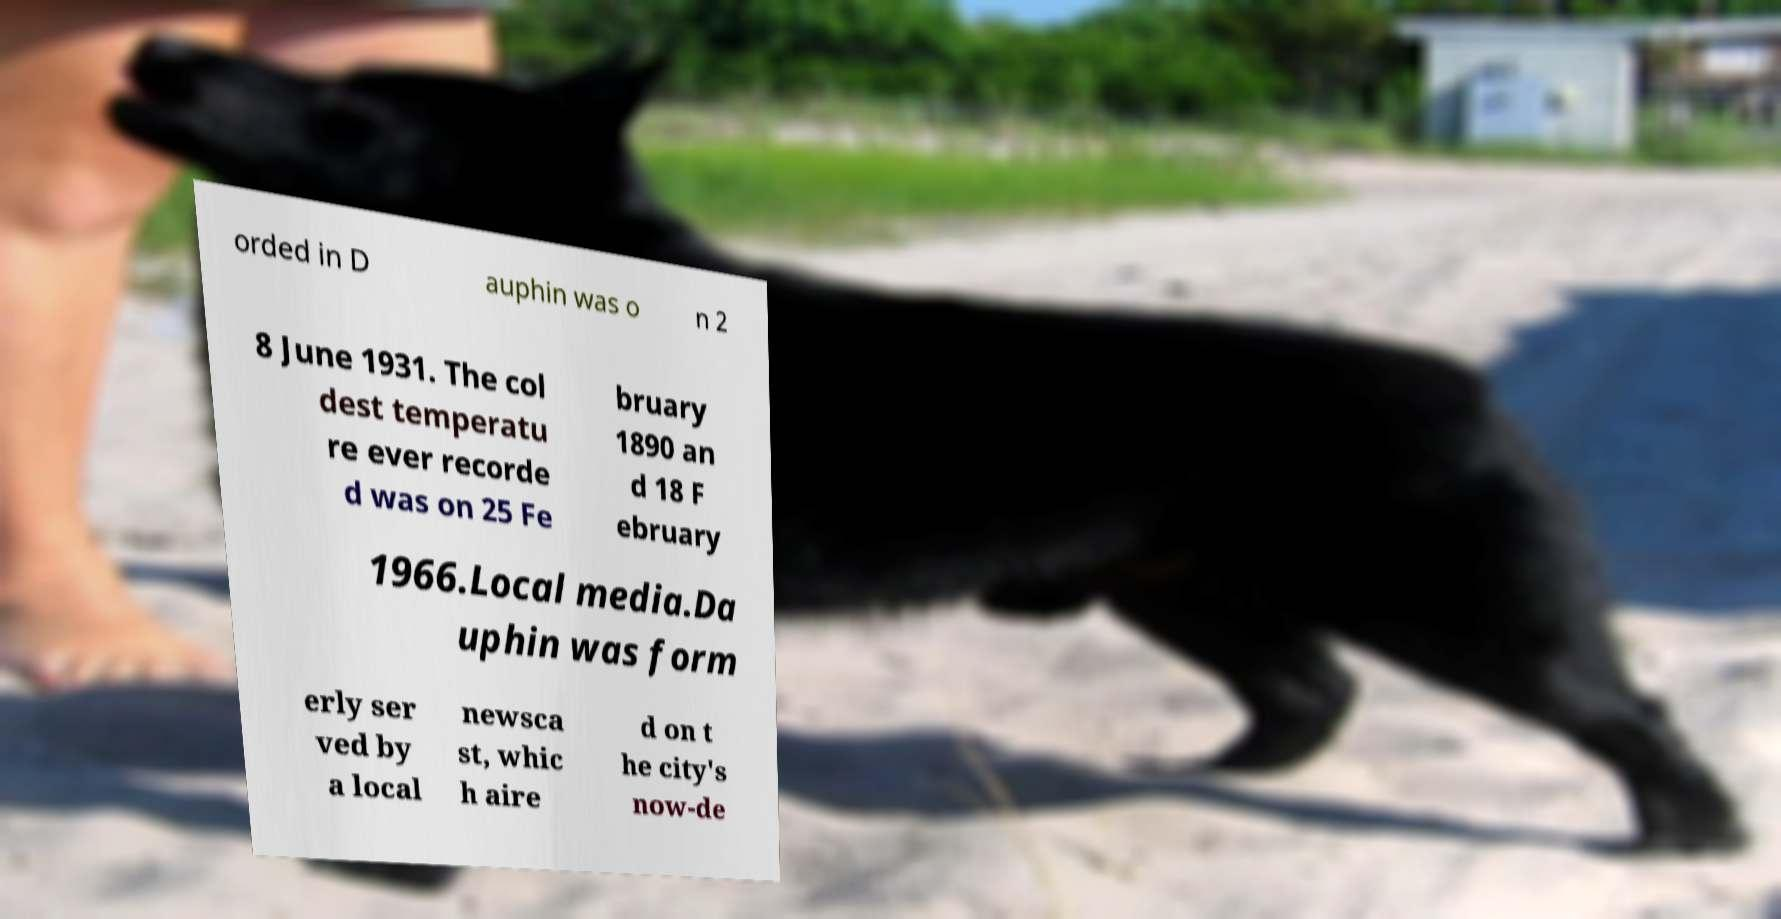Can you read and provide the text displayed in the image?This photo seems to have some interesting text. Can you extract and type it out for me? orded in D auphin was o n 2 8 June 1931. The col dest temperatu re ever recorde d was on 25 Fe bruary 1890 an d 18 F ebruary 1966.Local media.Da uphin was form erly ser ved by a local newsca st, whic h aire d on t he city's now-de 